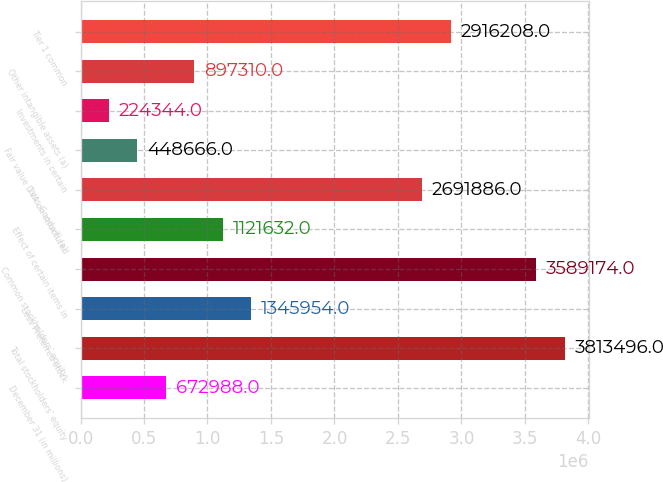Convert chart to OTSL. <chart><loc_0><loc_0><loc_500><loc_500><bar_chart><fcel>December 31 (in millions)<fcel>Total stockholders' equity<fcel>Less Preferred stock<fcel>Common stockholders' equity<fcel>Effect of certain items in<fcel>Less Goodwill (a)<fcel>Fair value DVA on structured<fcel>Investments in certain<fcel>Other intangible assets (a)<fcel>Tier 1 common<nl><fcel>672988<fcel>3.8135e+06<fcel>1.34595e+06<fcel>3.58917e+06<fcel>1.12163e+06<fcel>2.69189e+06<fcel>448666<fcel>224344<fcel>897310<fcel>2.91621e+06<nl></chart> 